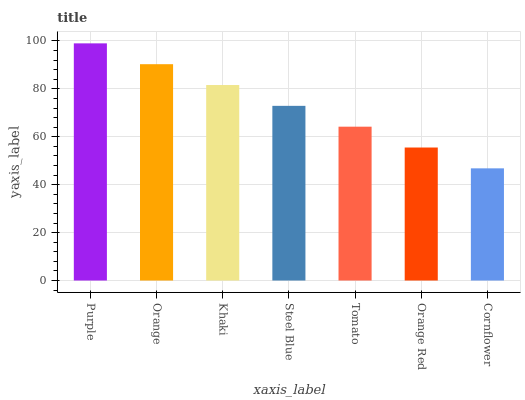Is Cornflower the minimum?
Answer yes or no. Yes. Is Purple the maximum?
Answer yes or no. Yes. Is Orange the minimum?
Answer yes or no. No. Is Orange the maximum?
Answer yes or no. No. Is Purple greater than Orange?
Answer yes or no. Yes. Is Orange less than Purple?
Answer yes or no. Yes. Is Orange greater than Purple?
Answer yes or no. No. Is Purple less than Orange?
Answer yes or no. No. Is Steel Blue the high median?
Answer yes or no. Yes. Is Steel Blue the low median?
Answer yes or no. Yes. Is Purple the high median?
Answer yes or no. No. Is Cornflower the low median?
Answer yes or no. No. 